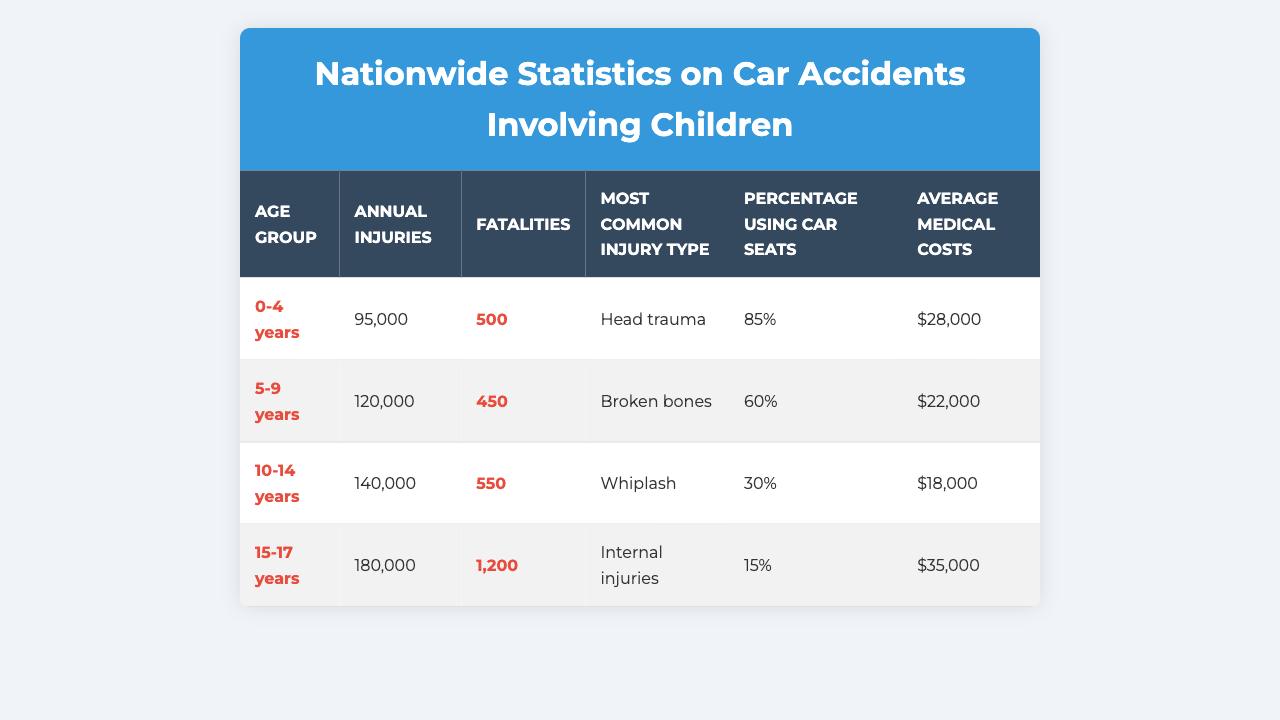What age group has the highest annual injuries? The table shows that the age group 15-17 years has the highest number of annual injuries at 180,000.
Answer: 15-17 years How many fatalities are recorded for children aged 0-4 years? According to the table, there are 500 fatalities for the age group 0-4 years.
Answer: 500 What is the most common injury type for children aged 5-9 years? The table indicates that the most common injury type for children aged 5-9 years is broken bones.
Answer: Broken bones What age group has the lowest percentage using car seats? The age group with the lowest percentage using car seats is 15-17 years, with only 15% using them.
Answer: 15-17 years What are the average medical costs for children aged 10-14 years? The average medical costs for children aged 10-14 years, as per the table, are $18,000.
Answer: $18,000 If we sum the annual injuries across all age groups, what does that total? Adding the annual injuries for each age group gives: 95,000 + 120,000 + 140,000 + 180,000 = 535,000 total injuries.
Answer: 535,000 Is the average medical cost for children aged 0-4 years higher than for 10-14 years? The average medical cost for 0-4 years is $28,000 while for 10-14 years it is $18,000, showing that 0-4 years has a higher cost.
Answer: Yes What is the percentage difference in fatalities between the age groups 0-4 years and 15-17 years? The difference in fatalities is 1,200 (15-17 years) - 500 (0-4 years) = 700. Calculating the percentage difference: (700 / 500) * 100 = 140%.
Answer: 140% Which age group has the highest average medical costs? According to the table, the age group 15-17 years has the highest average medical costs at $35,000.
Answer: 15-17 years How many more annual injuries are there in the 10-14 years group compared to the 5-9 years group? The annual injuries for 10-14 years is 140,000 and for 5-9 years is 120,000. The difference is 140,000 - 120,000 = 20,000.
Answer: 20,000 What is the average medical cost across all age groups? The average medical cost is calculated by summing the costs: $28,000 + $22,000 + $18,000 + $35,000 = $103,000. Then, divide by 4 age groups: $103,000 / 4 = $25,750.
Answer: $25,750 